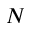Convert formula to latex. <formula><loc_0><loc_0><loc_500><loc_500>N</formula> 